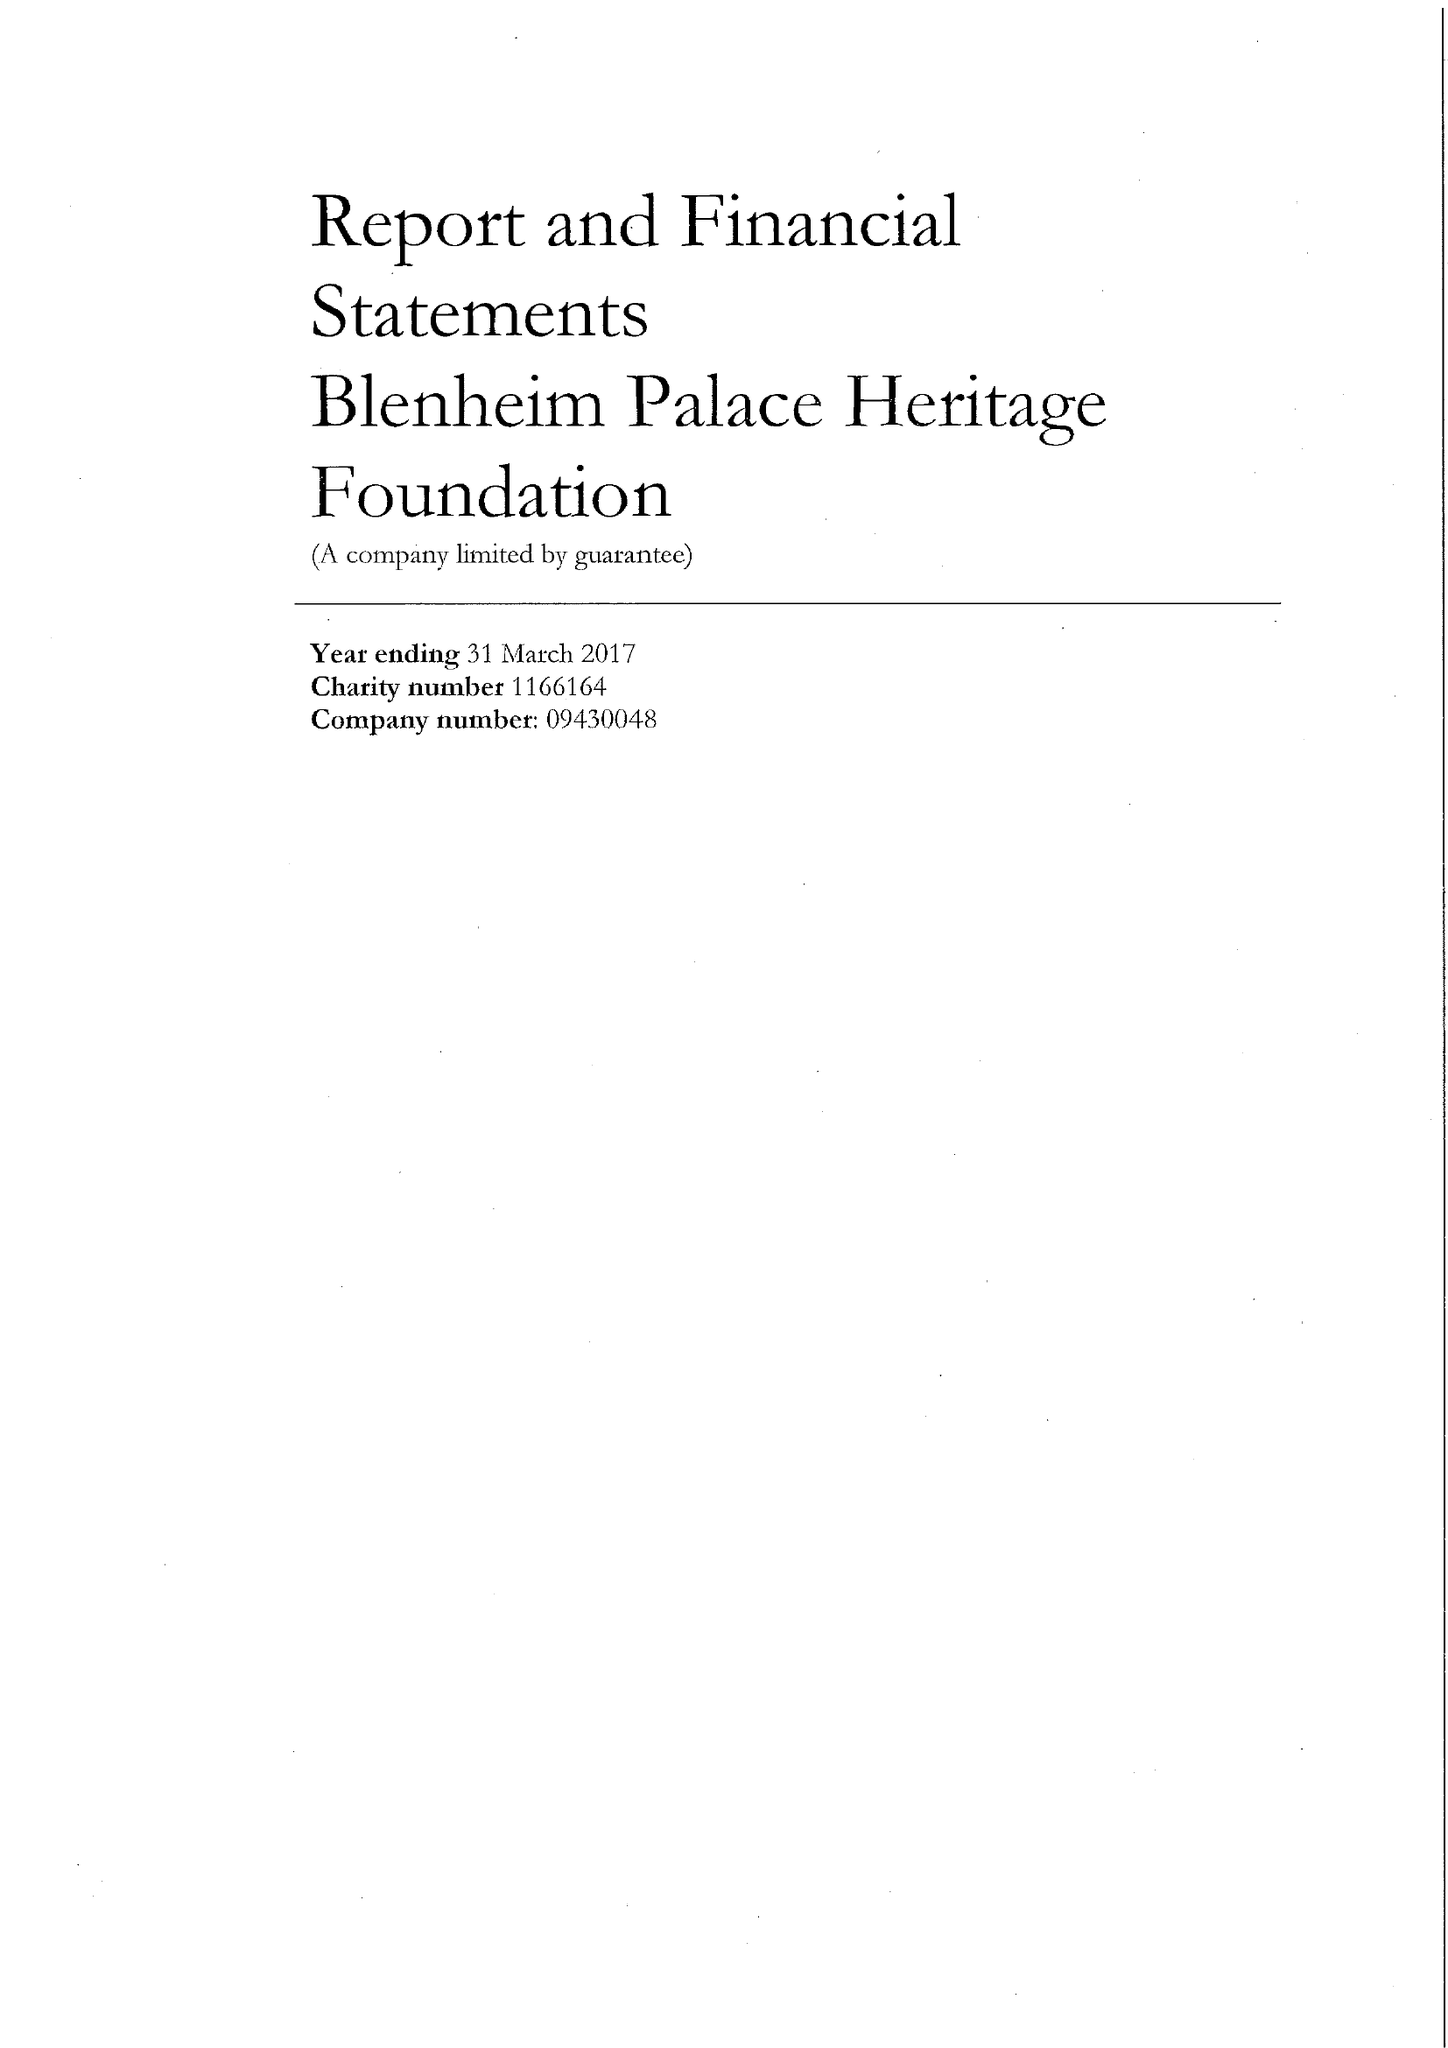What is the value for the address__street_line?
Answer the question using a single word or phrase. None 